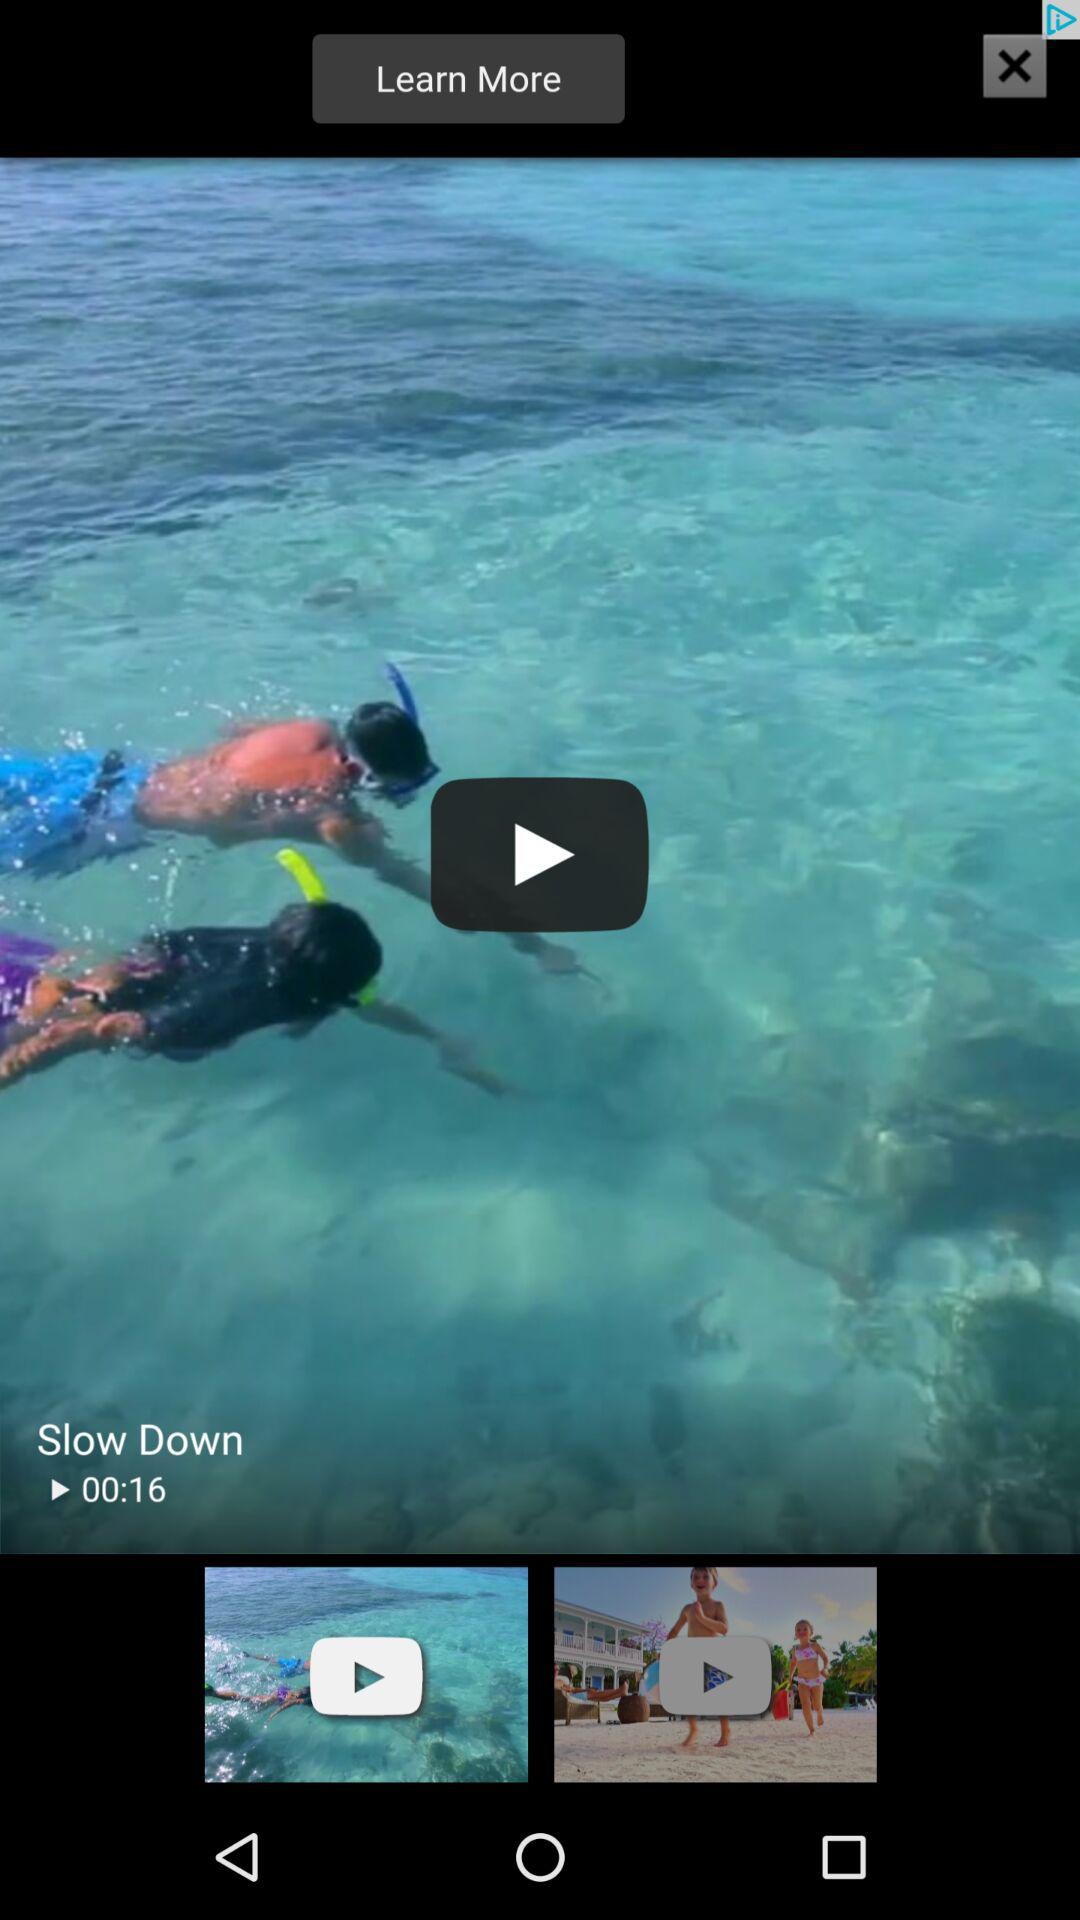How many seconds long is the video?
Answer the question using a single word or phrase. 16 